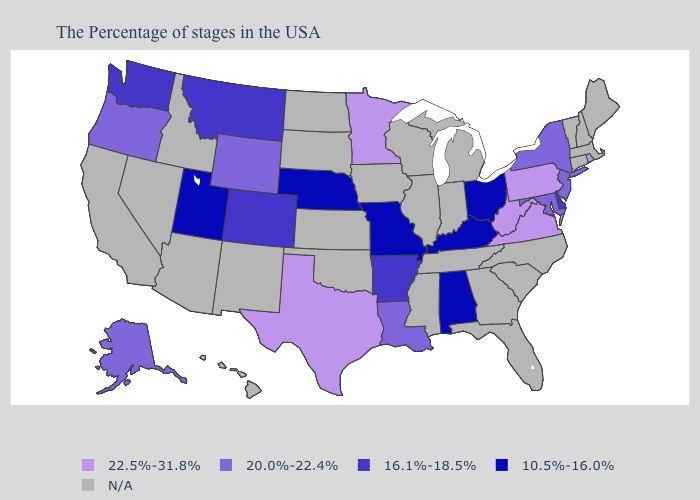Name the states that have a value in the range 20.0%-22.4%?
Short answer required. New York, New Jersey, Maryland, Louisiana, Wyoming, Oregon, Alaska. Which states have the lowest value in the South?
Write a very short answer. Kentucky, Alabama. Does the map have missing data?
Write a very short answer. Yes. What is the value of Delaware?
Give a very brief answer. 16.1%-18.5%. Does Nebraska have the lowest value in the USA?
Keep it brief. Yes. Does the first symbol in the legend represent the smallest category?
Quick response, please. No. What is the highest value in the USA?
Be succinct. 22.5%-31.8%. Among the states that border West Virginia , which have the highest value?
Concise answer only. Pennsylvania, Virginia. What is the lowest value in states that border Wyoming?
Give a very brief answer. 10.5%-16.0%. Name the states that have a value in the range 10.5%-16.0%?
Keep it brief. Ohio, Kentucky, Alabama, Missouri, Nebraska, Utah. Which states hav the highest value in the South?
Keep it brief. Virginia, West Virginia, Texas. What is the value of Hawaii?
Quick response, please. N/A. What is the lowest value in the USA?
Answer briefly. 10.5%-16.0%. 